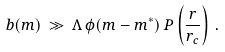Convert formula to latex. <formula><loc_0><loc_0><loc_500><loc_500>b ( m ) \, \gg \, \Lambda \, \phi ( m - m ^ { * } ) \, P \left ( \frac { r } { r _ { c } } \right ) \, .</formula> 